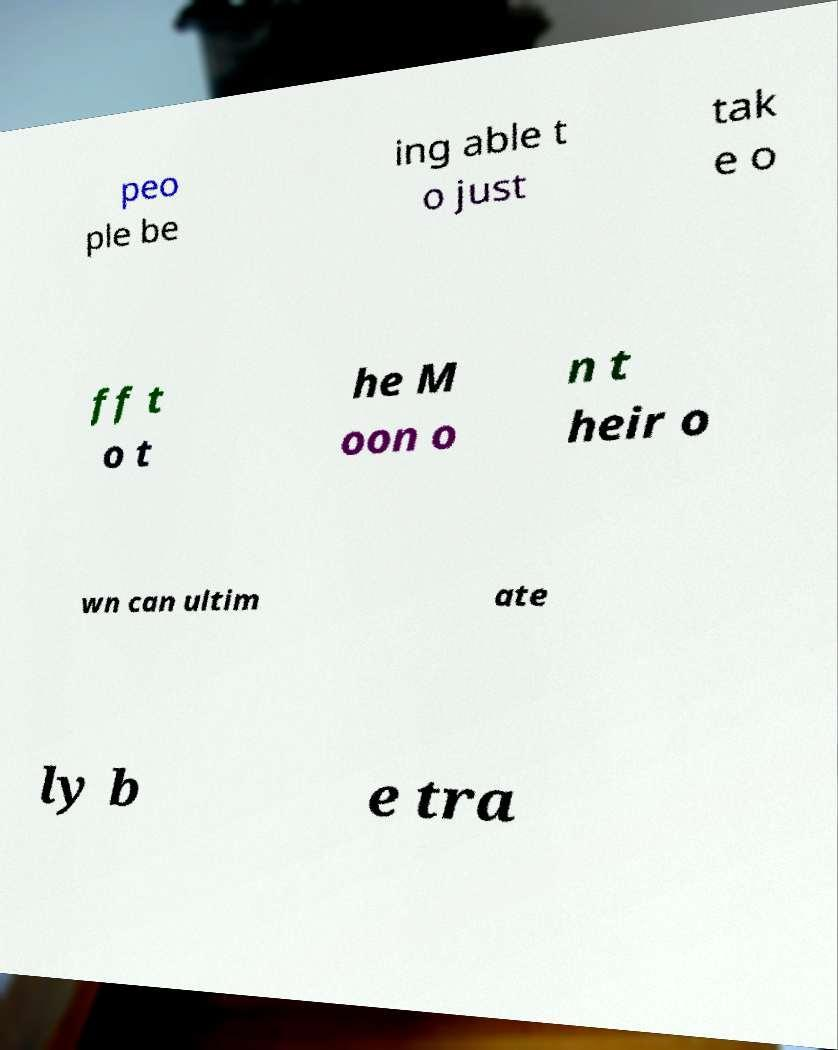I need the written content from this picture converted into text. Can you do that? peo ple be ing able t o just tak e o ff t o t he M oon o n t heir o wn can ultim ate ly b e tra 